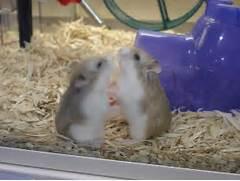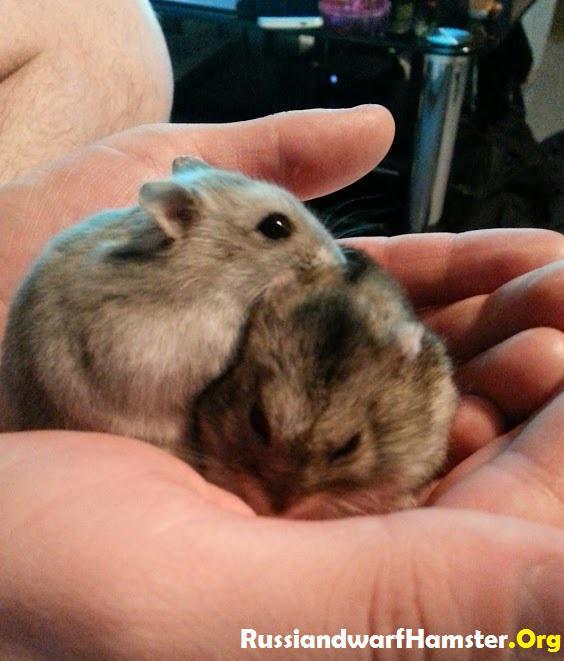The first image is the image on the left, the second image is the image on the right. Given the left and right images, does the statement "There are two pairs of hamsters" hold true? Answer yes or no. Yes. The first image is the image on the left, the second image is the image on the right. Considering the images on both sides, is "Cupped hands hold at least one pet rodent in one image." valid? Answer yes or no. Yes. 